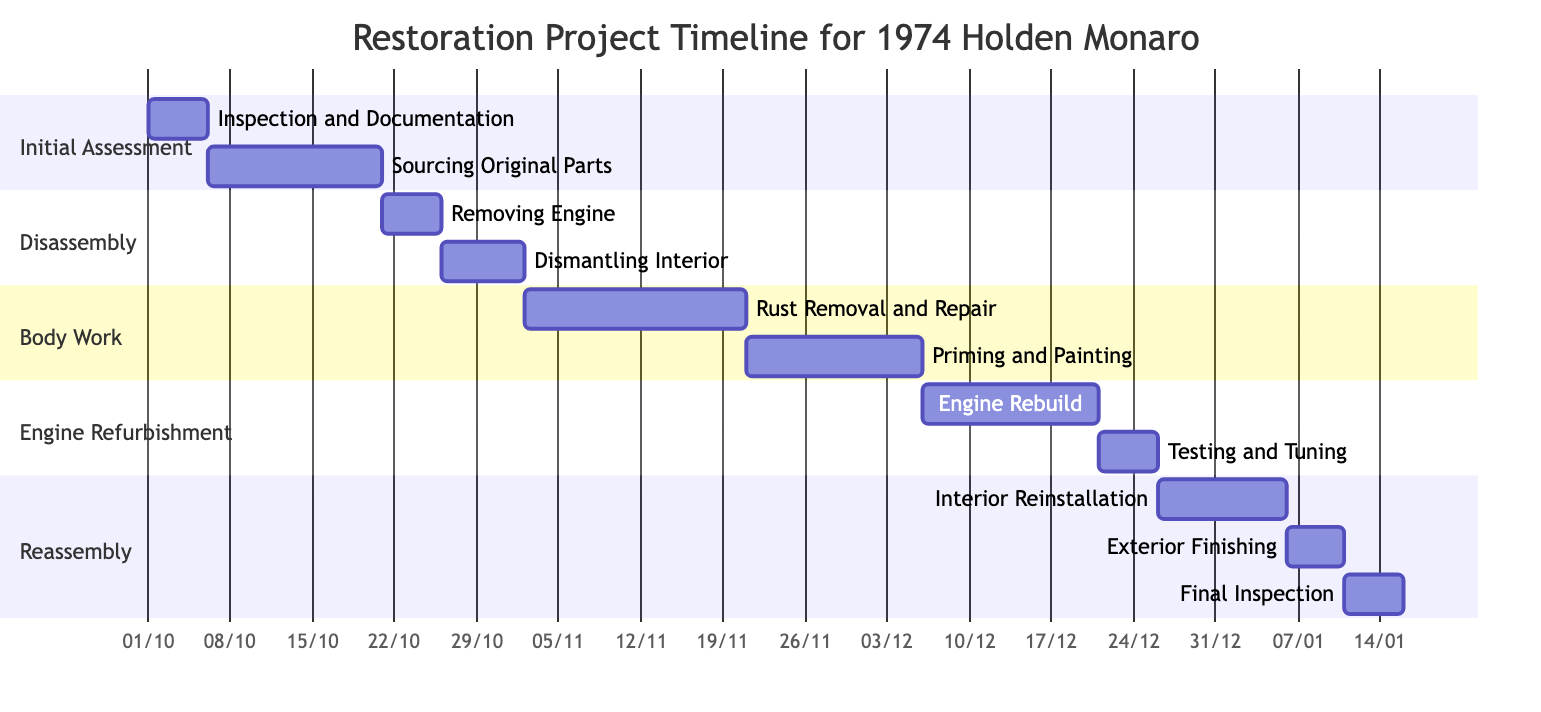What is the duration of the "Inspection and Documentation" task? The "Inspection and Documentation" task starts on October 1, 2023, and ends on October 5, 2023. By counting the days from the start date to the end date inclusive, it lasts for 5 days.
Answer: 5 days How many tasks are there in the "Disassembly" phase? The "Disassembly" phase contains two tasks: "Removing Engine" and "Dismantling Interior". Therefore, the total count of tasks in this phase is 2.
Answer: 2 What is the start date of the "Rust Removal and Repair" task? Looking at the diagram, the "Rust Removal and Repair" task starts right after "Dismantling Interior" finishes. "Dismantling Interior" ends on November 1, 2023, making "Rust Removal and Repair" start on November 2, 2023.
Answer: November 2, 2023 Which task has the longest duration? By analyzing the durations of each task, "Rust Removal and Repair" spans 19 days, which is the longest compared to other tasks that have shorter durations.
Answer: 19 days When does the last task "Final Inspection" begin? The "Final Inspection" task follows "Exterior Finishing", which ends on January 10, 2024. Therefore, "Final Inspection" begins right after that on January 11, 2024.
Answer: January 11, 2024 Who is involved in the "Engine Rebuild" task? The resources assigned to "Engine Rebuild" are "Engine Specialist" and "John the Mechanic", indicating that both are involved in carrying out this task.
Answer: Engine Specialist, John the Mechanic How many days are allocated for "Testing and Tuning"? The "Testing and Tuning" task starts on December 21, 2023, and ends on December 25, 2023. Counting these days gives a total duration of 5 days.
Answer: 5 days What tasks are completed before "Exterior Finishing"? "Interior Reinstallation" needs to be completed before "Exterior Finishing" can start, as indicated by the sequential flow in the Gantt chart.
Answer: Interior Reinstallation What is the overall time frame for the entire restoration project? The project commences on October 1, 2023, with the first task and concludes on January 15, 2024, with the final task. The overall time frame is from start to finish spanning roughly 3 and a half months.
Answer: October 1, 2023 - January 15, 2024 